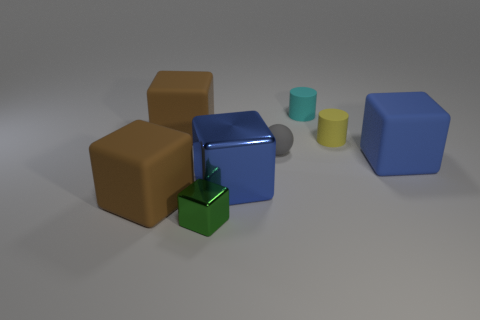Subtract all blue matte cubes. How many cubes are left? 4 Subtract all green cylinders. How many brown blocks are left? 2 Add 2 purple matte blocks. How many objects exist? 10 Subtract all green blocks. How many blocks are left? 4 Subtract 1 blocks. How many blocks are left? 4 Subtract 0 cyan blocks. How many objects are left? 8 Subtract all cylinders. How many objects are left? 6 Subtract all purple cubes. Subtract all purple cylinders. How many cubes are left? 5 Subtract all large blue blocks. Subtract all large blue things. How many objects are left? 4 Add 1 cyan rubber objects. How many cyan rubber objects are left? 2 